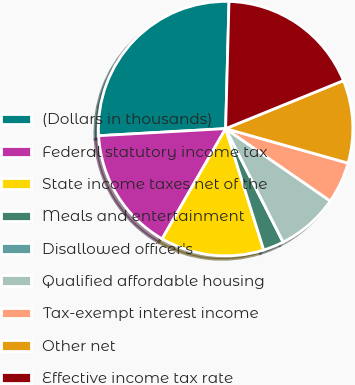Convert chart. <chart><loc_0><loc_0><loc_500><loc_500><pie_chart><fcel>(Dollars in thousands)<fcel>Federal statutory income tax<fcel>State income taxes net of the<fcel>Meals and entertainment<fcel>Disallowed officer's<fcel>Qualified affordable housing<fcel>Tax-exempt interest income<fcel>Other net<fcel>Effective income tax rate<nl><fcel>26.31%<fcel>15.79%<fcel>13.16%<fcel>2.63%<fcel>0.0%<fcel>7.9%<fcel>5.26%<fcel>10.53%<fcel>18.42%<nl></chart> 